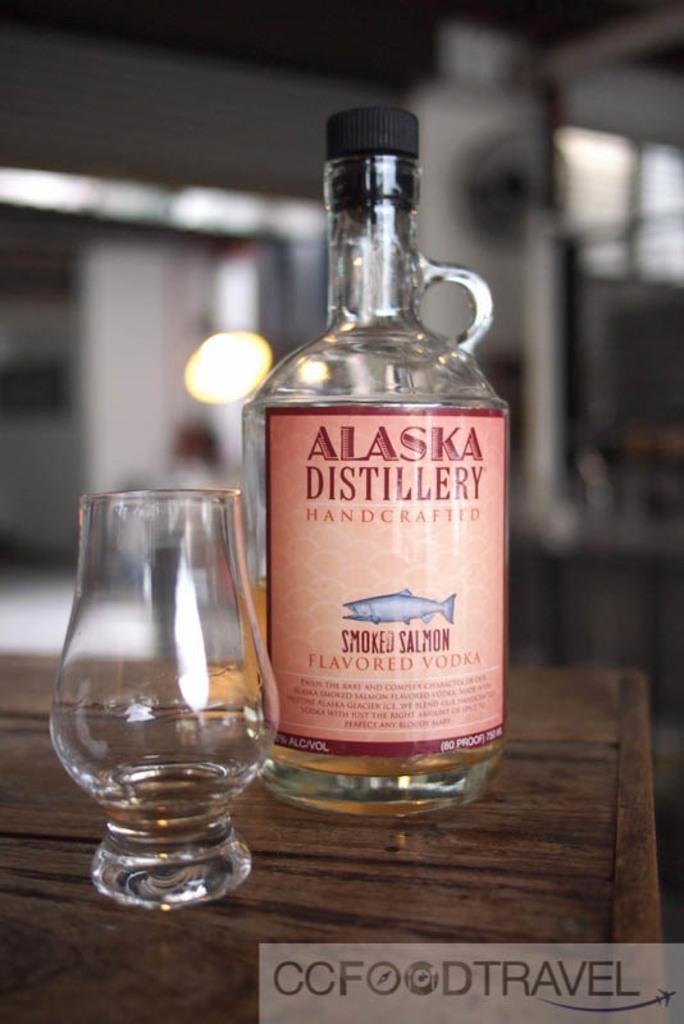What is the name of this drink?
Offer a terse response. Smoked salmon. What is the flavor?
Provide a succinct answer. Smoked salmon. 